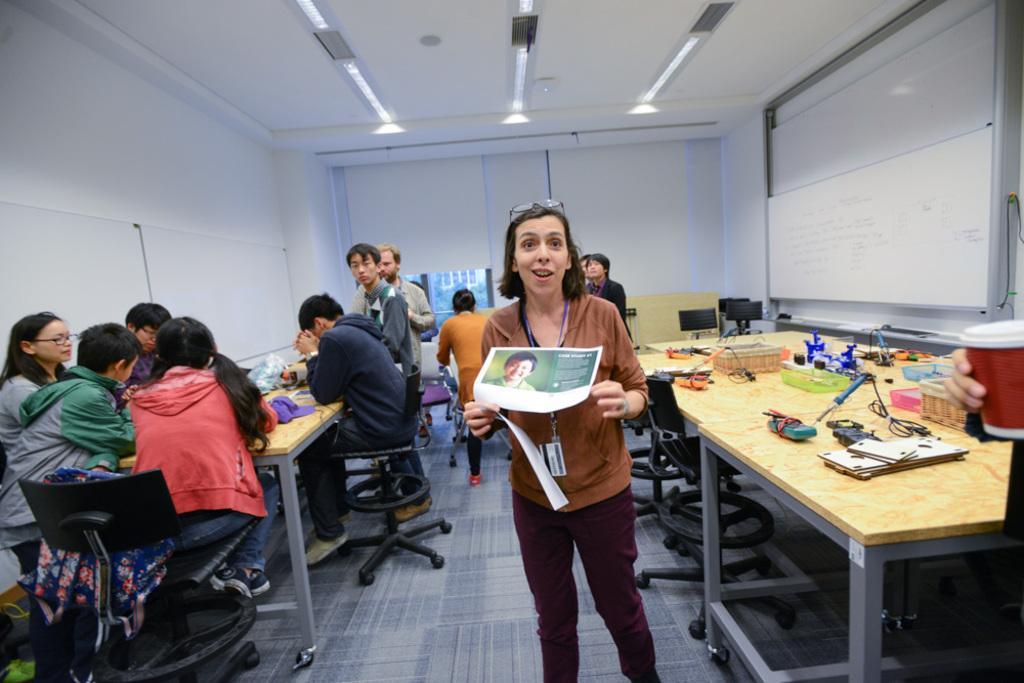Could you give a brief overview of what you see in this image? This is a picture of a classroom. on the right there is a board. Towards the right there are tables and chairs, on the table there are boxes. In the background there is a window. On the top it is ceiling and light. In the center there is a woman standing and holding a paper. On the left there are few people seated around the table. 